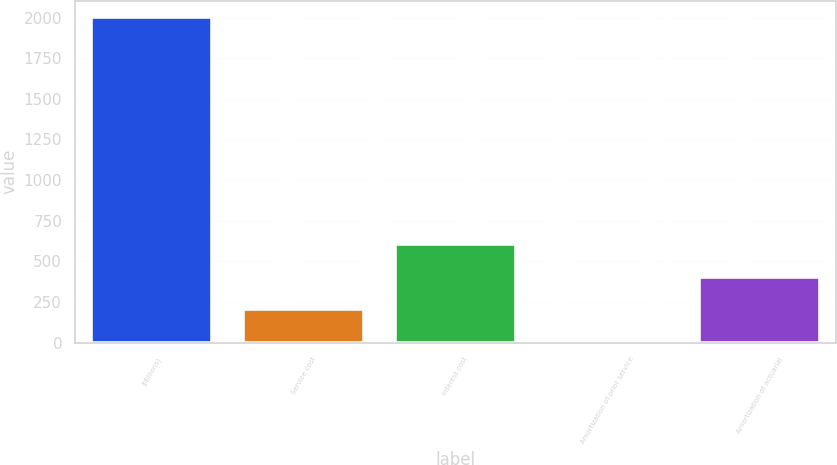<chart> <loc_0><loc_0><loc_500><loc_500><bar_chart><fcel>(Millions)<fcel>Service cost<fcel>Interest cost<fcel>Amortization of prior service<fcel>Amortization of actuarial<nl><fcel>2004<fcel>205.8<fcel>605.4<fcel>6<fcel>405.6<nl></chart> 